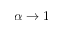Convert formula to latex. <formula><loc_0><loc_0><loc_500><loc_500>\alpha \rightarrow 1</formula> 